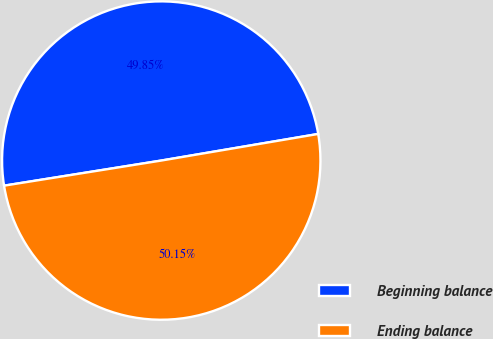Convert chart. <chart><loc_0><loc_0><loc_500><loc_500><pie_chart><fcel>Beginning balance<fcel>Ending balance<nl><fcel>49.85%<fcel>50.15%<nl></chart> 